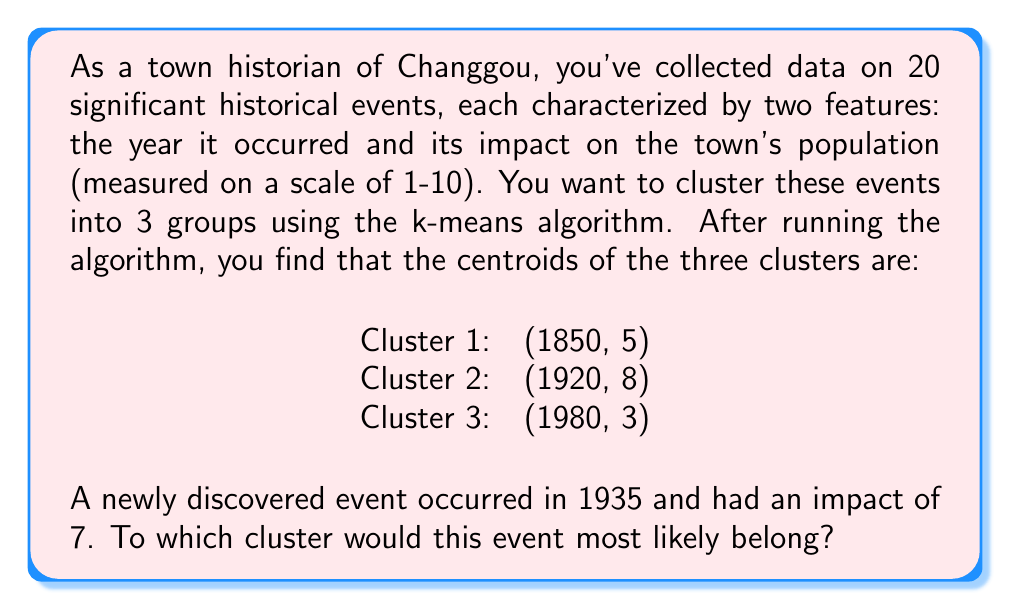Could you help me with this problem? To determine which cluster the new event belongs to, we need to calculate the Euclidean distance between the event and each cluster centroid. The event will be assigned to the cluster with the smallest distance.

Let's denote the new event as $E(1935, 7)$ and calculate its distance to each centroid:

1. Distance to Cluster 1 centroid $C_1(1850, 5)$:
   $$d_1 = \sqrt{(1935-1850)^2 + (7-5)^2} = \sqrt{85^2 + 2^2} = \sqrt{7229} \approx 85.02$$

2. Distance to Cluster 2 centroid $C_2(1920, 8)$:
   $$d_2 = \sqrt{(1935-1920)^2 + (7-8)^2} = \sqrt{15^2 + (-1)^2} = \sqrt{226} \approx 15.03$$

3. Distance to Cluster 3 centroid $C_3(1980, 3)$:
   $$d_3 = \sqrt{(1935-1980)^2 + (7-3)^2} = \sqrt{(-45)^2 + 4^2} = \sqrt{2025 + 16} = \sqrt{2041} \approx 45.18$$

Comparing these distances:
$d_2 < d_3 < d_1$

The smallest distance is $d_2$, which corresponds to Cluster 2.
Answer: Cluster 2 